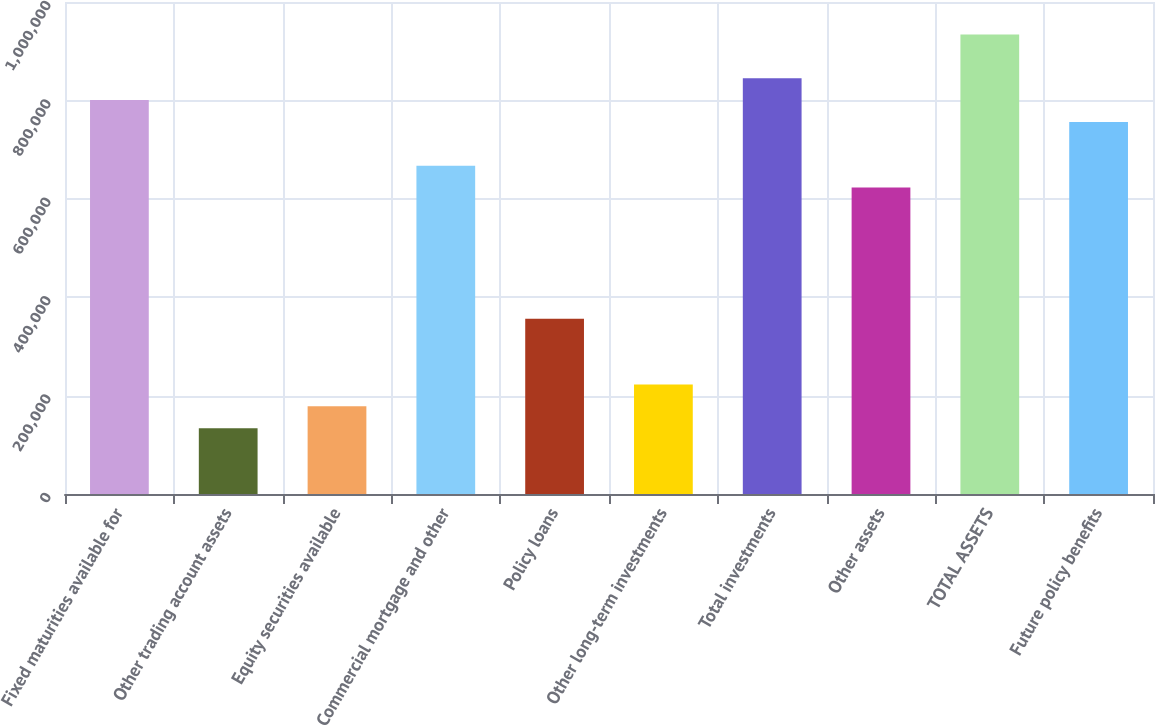Convert chart to OTSL. <chart><loc_0><loc_0><loc_500><loc_500><bar_chart><fcel>Fixed maturities available for<fcel>Other trading account assets<fcel>Equity securities available<fcel>Commercial mortgage and other<fcel>Policy loans<fcel>Other long-term investments<fcel>Total investments<fcel>Other assets<fcel>TOTAL ASSETS<fcel>Future policy benefits<nl><fcel>800653<fcel>133825<fcel>178280<fcel>667287<fcel>356101<fcel>222735<fcel>845108<fcel>622832<fcel>934018<fcel>756197<nl></chart> 